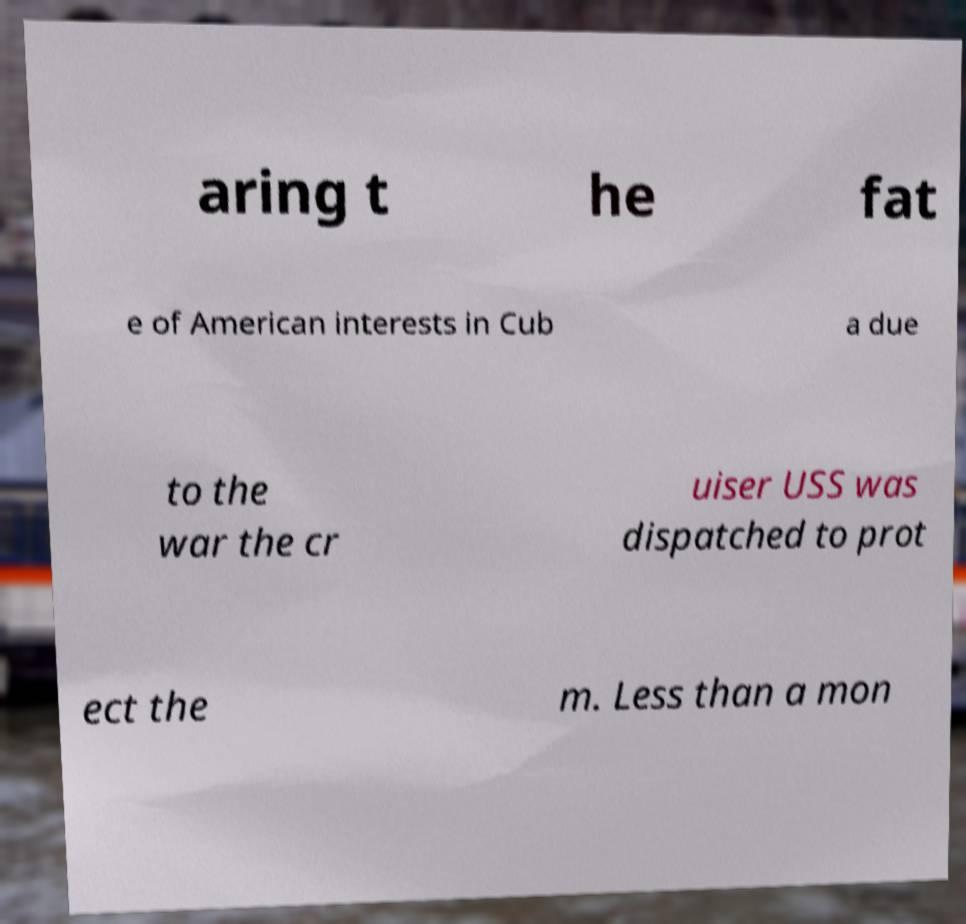There's text embedded in this image that I need extracted. Can you transcribe it verbatim? aring t he fat e of American interests in Cub a due to the war the cr uiser USS was dispatched to prot ect the m. Less than a mon 